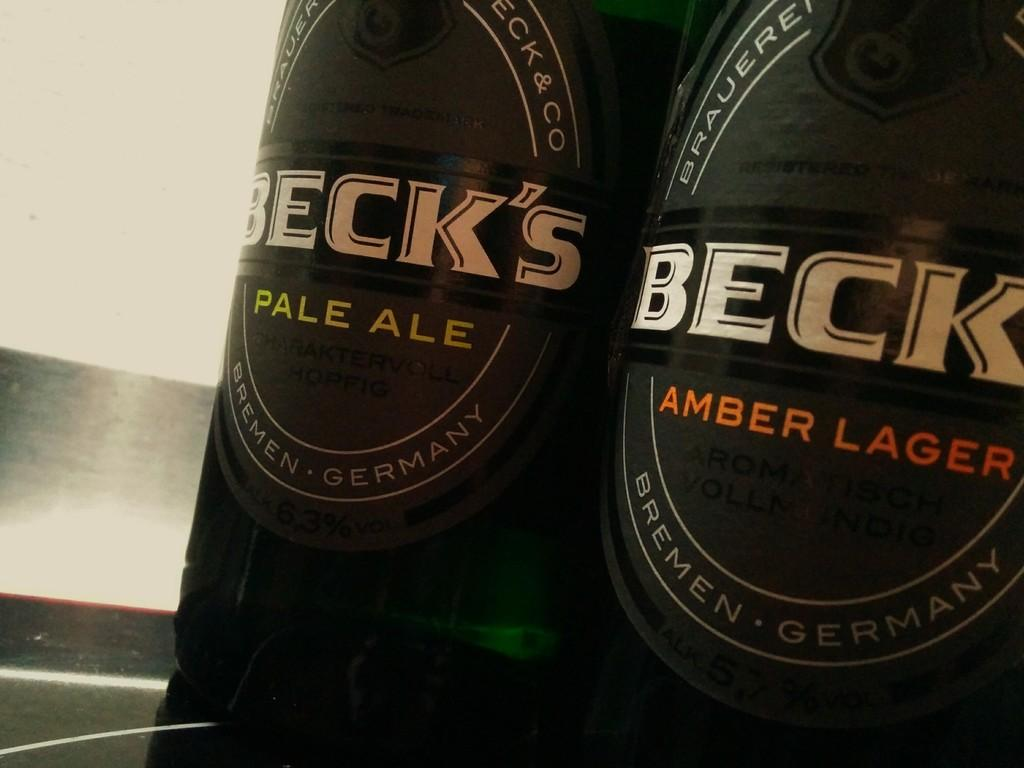<image>
Share a concise interpretation of the image provided. Two different bottles of Beck's beer, both made in Germany. 